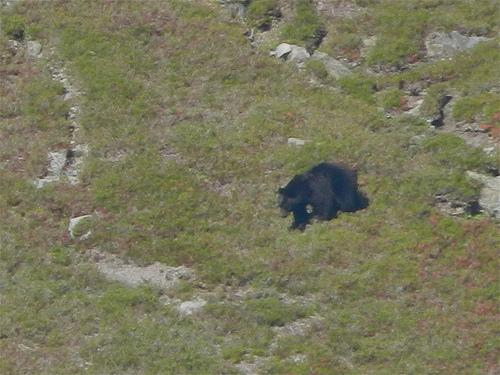Tell me about the vegetation in the image. The image features green grazing grasses and a field of thinning green grass with some brown patches, along with some small orange flowers. Choose a product best suited for this image for an advertisement, and explain how the image could be used to promote it. A nature documentary about black bears is a suitable product for this image. The advertisement could showcase the bear in its wild habitat and highlight the beauty of the surrounding environment. Describe the color and quality of the grass in the image. The grass in the image is green and patchy, with some parts that are thinning and some small patches of dirt and sand. Provide a concise description about the terrain where the black bear is found in the image. The terrain consists of a grassy field with patches of dirt and rocks, and sand in the grass, possibly near the edge of a pond. Identify the key inanimate landmark in the image and describe its surrounding environment. A gray rock in the grass is a key inanimate landmark, surrounded by rocks and gravel on the ground and grass on the rock. Describe the environment in the image including the presence of any inanimate objects. The environment is a grassy field with patches of dirt, some rocks, sand, and small flowers. There is a rock formation within the grass, and a large rock on the hill. What is the most prominent creature in the image and where is it situated? A black bear is the most prominent creature in the image, walking in the grass with its head angled down towards the ground. In the context of the image, explain what the black bear is doing, and mention its notable physical features. The black bear is walking on all fours in the grass with its head angled down towards the ground. It has a brown nose and fuzzy black fur. What are the physical features of the black bear in the image? The black bear has a brown nose, fuzzy fur, and is walking on all fours with its head angled down towards the ground. 